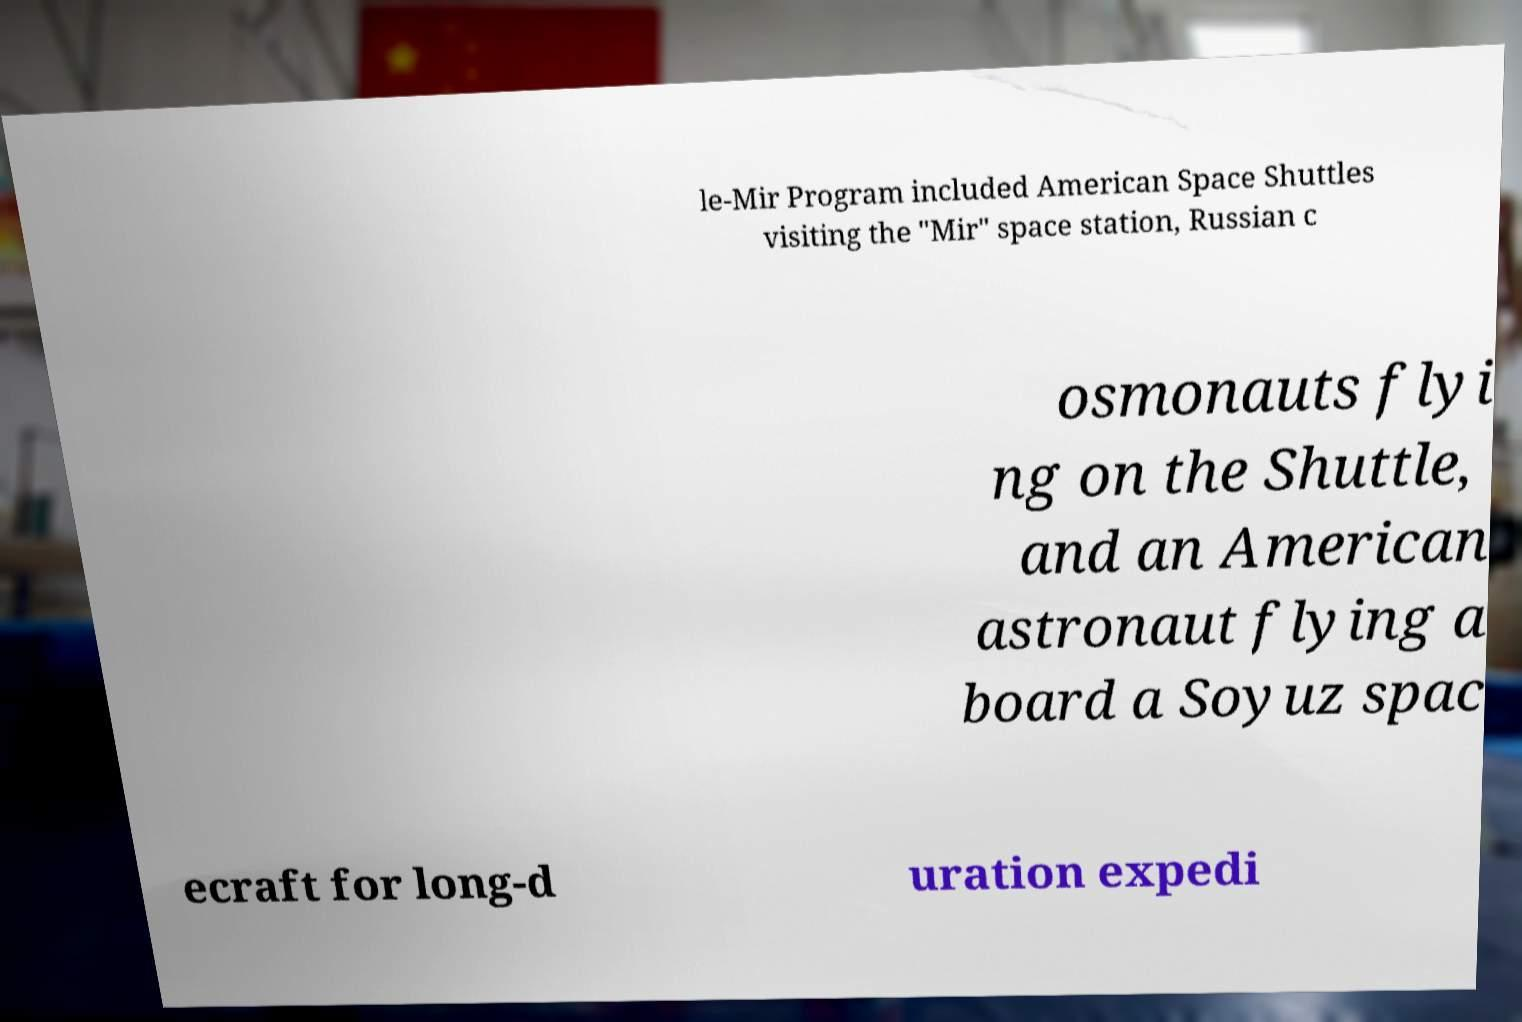What messages or text are displayed in this image? I need them in a readable, typed format. le-Mir Program included American Space Shuttles visiting the "Mir" space station, Russian c osmonauts flyi ng on the Shuttle, and an American astronaut flying a board a Soyuz spac ecraft for long-d uration expedi 